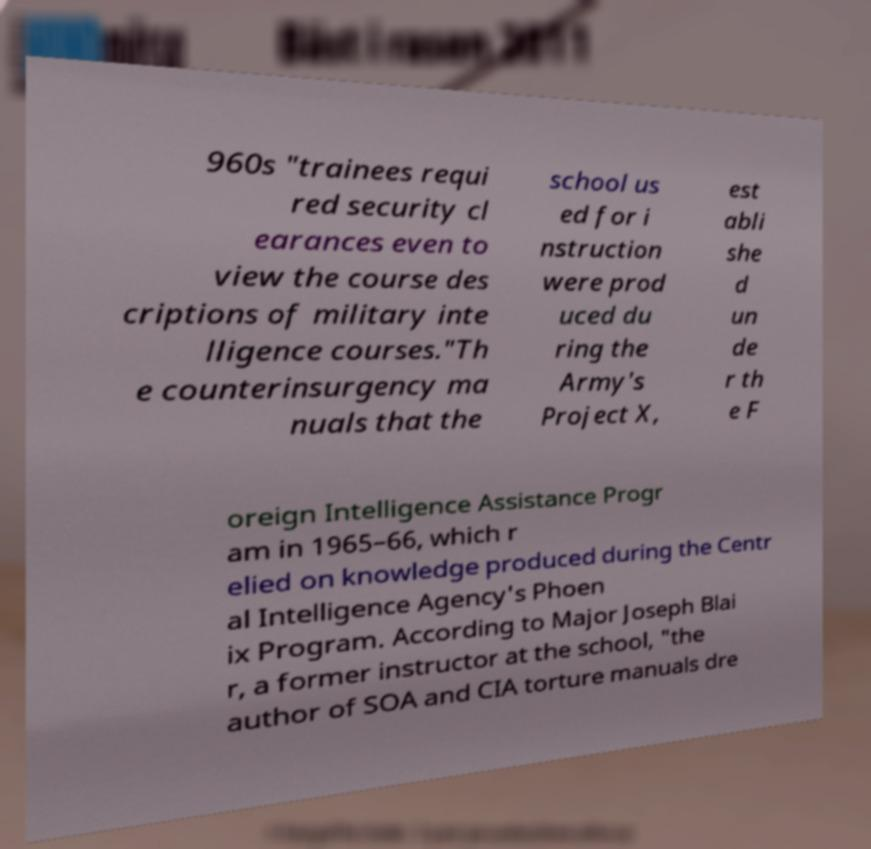What messages or text are displayed in this image? I need them in a readable, typed format. 960s "trainees requi red security cl earances even to view the course des criptions of military inte lligence courses."Th e counterinsurgency ma nuals that the school us ed for i nstruction were prod uced du ring the Army's Project X, est abli she d un de r th e F oreign Intelligence Assistance Progr am in 1965–66, which r elied on knowledge produced during the Centr al Intelligence Agency's Phoen ix Program. According to Major Joseph Blai r, a former instructor at the school, "the author of SOA and CIA torture manuals dre 